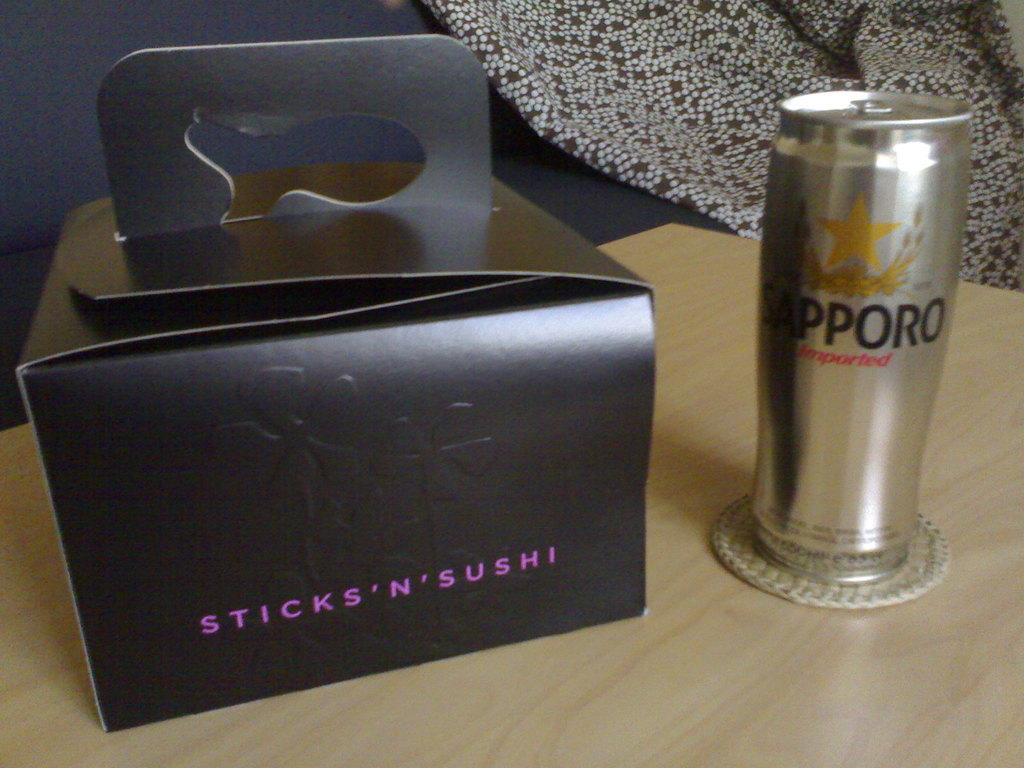Provide a one-sentence caption for the provided image. Sapporo drink next to a black box of Sticks N Sushi. 